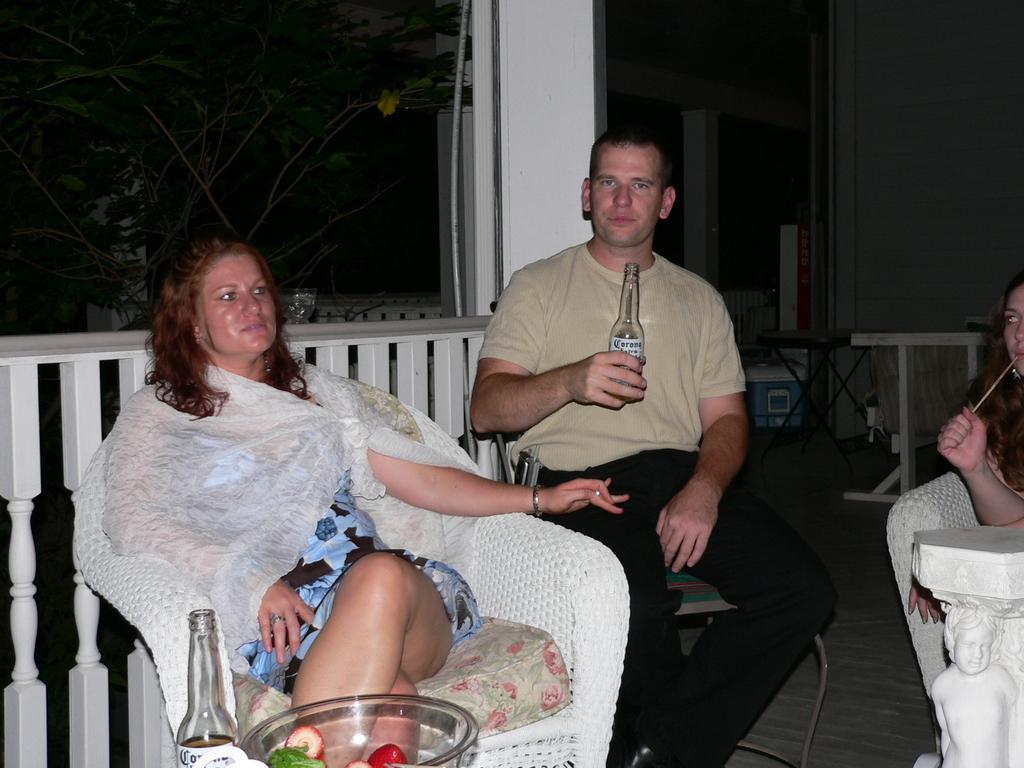Please provide a concise description of this image. In this image I can see a woman wearing white, blue and black colored dress is sitting on a couch which is white in color. I can see a bottle and a glass bowl in front of her with few fruits. I can see a person wearing cream and black colored dress is sitting and holding a bottle in his hand. In the background I can see the white colored railing, few trees, a house, a woman sitting and few other objects. 